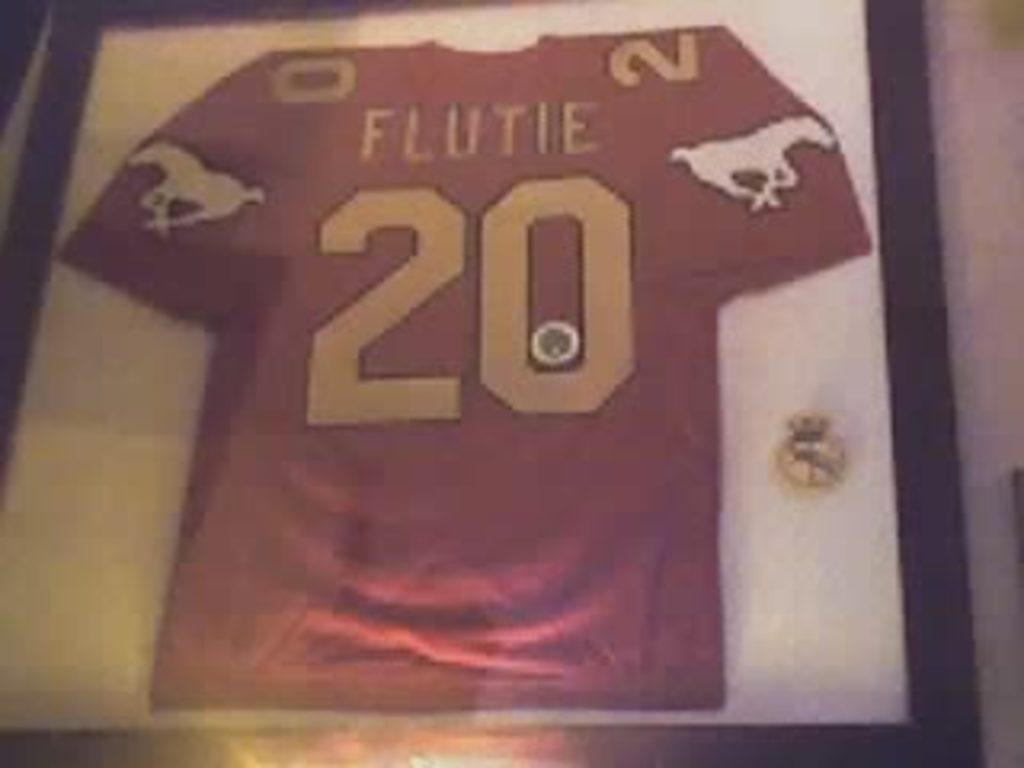<image>
Present a compact description of the photo's key features. A red Flutie jersey with a horse on it. 